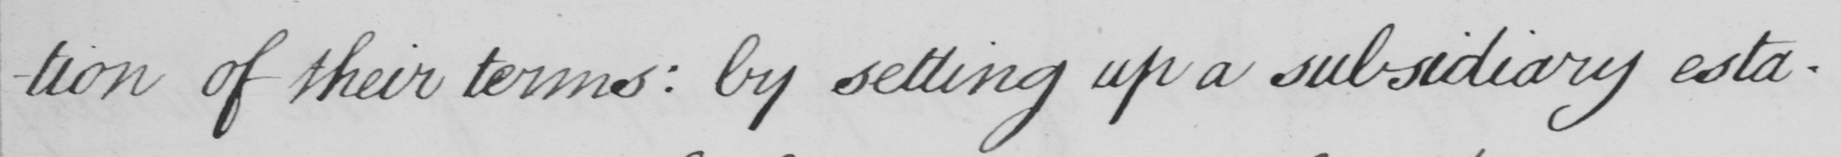What does this handwritten line say? -tion of their terms :  by setting up a subsidiary esta- 